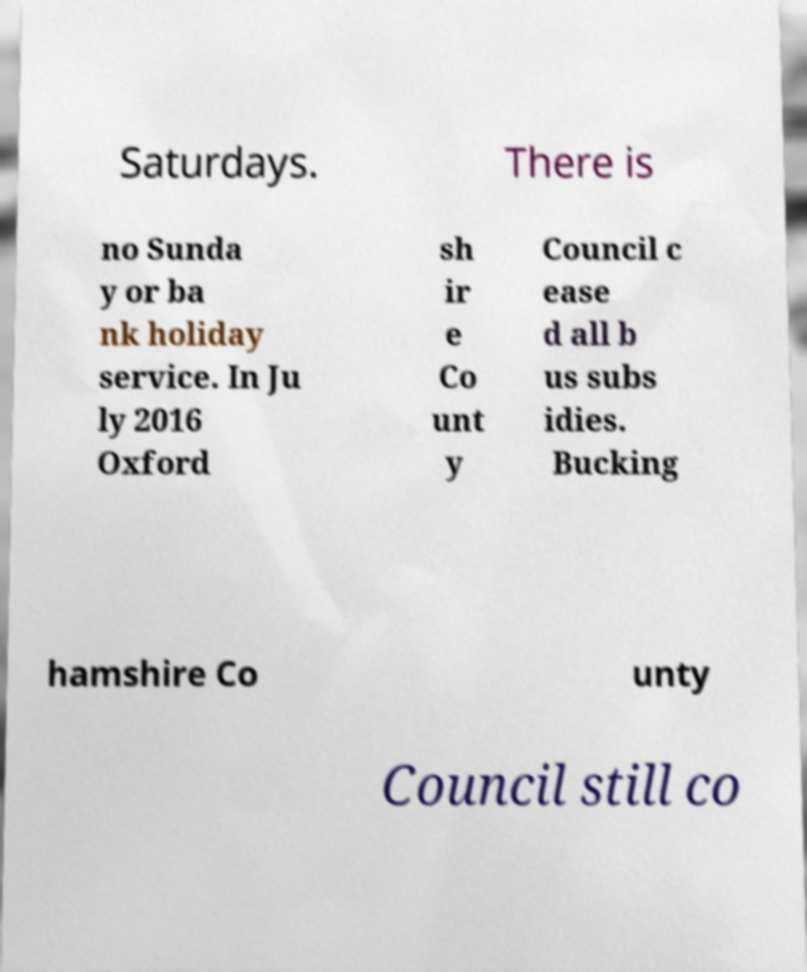Please identify and transcribe the text found in this image. Saturdays. There is no Sunda y or ba nk holiday service. In Ju ly 2016 Oxford sh ir e Co unt y Council c ease d all b us subs idies. Bucking hamshire Co unty Council still co 